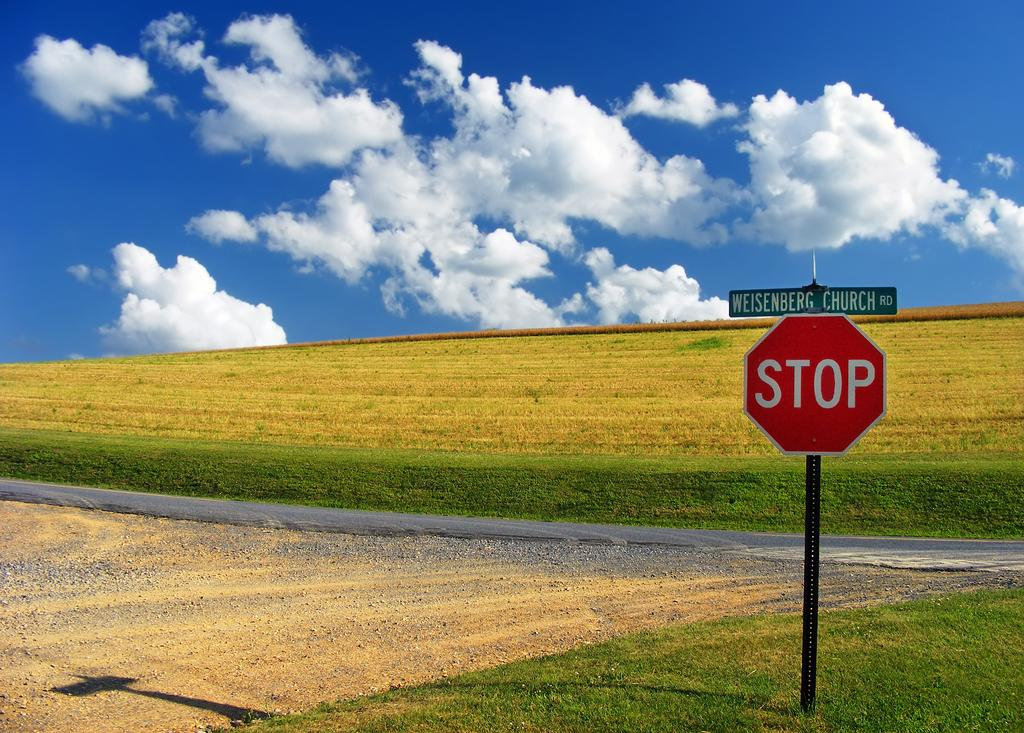<image>
Create a compact narrative representing the image presented. a stop sign that is among a very large field 